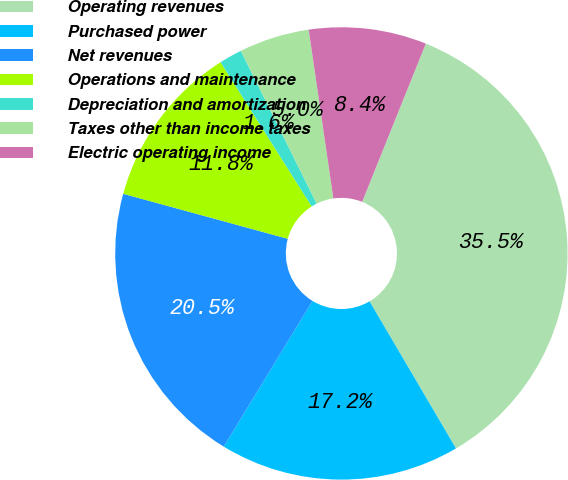<chart> <loc_0><loc_0><loc_500><loc_500><pie_chart><fcel>Operating revenues<fcel>Purchased power<fcel>Net revenues<fcel>Operations and maintenance<fcel>Depreciation and amortization<fcel>Taxes other than income taxes<fcel>Electric operating income<nl><fcel>35.45%<fcel>17.16%<fcel>20.54%<fcel>11.78%<fcel>1.64%<fcel>5.02%<fcel>8.4%<nl></chart> 